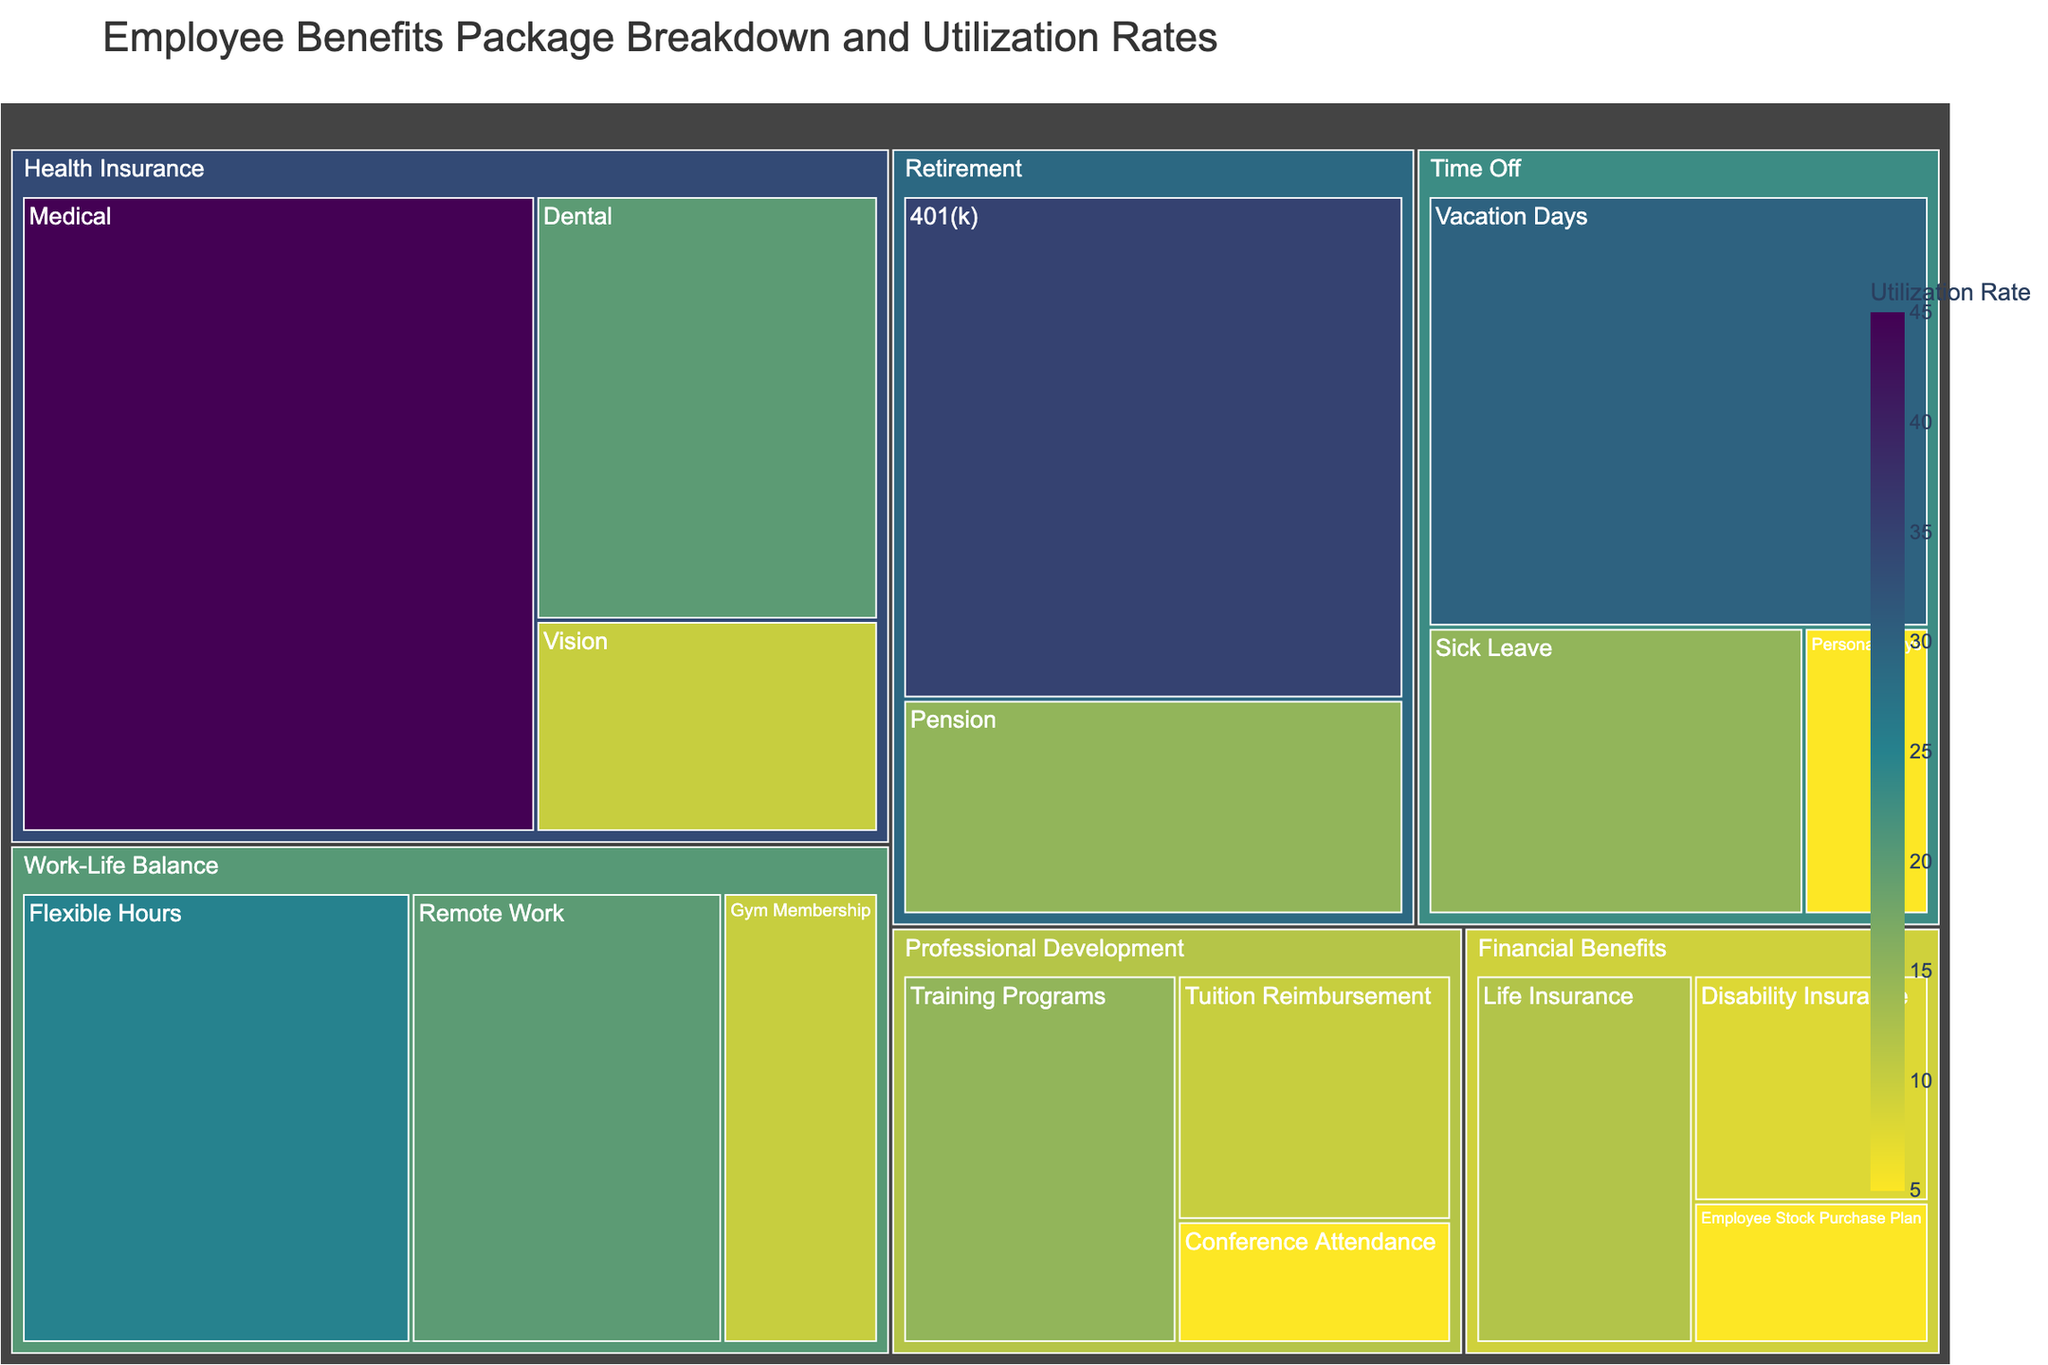What is the Utilization Rate of Medical benefits under Health Insurance? The Medical subcategory under Health Insurance has a Utilization Rate of 45 as shown in the figure.
Answer: 45 Which subcategory under Professional Development has the lowest Utilization Rate? Under Professional Development, Conference Attendance has the lowest Utilization Rate of 5 as depicted in the figure.
Answer: Conference Attendance What is the total Utilization Rate for all subcategories under Retirement? The subcategories under Retirement are 401(k) with 35 and Pension with 15. Summing these gives 35 + 15 = 50.
Answer: 50 Compare the Utilization Rates of Vacation Days and Flexible Hours. Which one is higher? Vacation Days has a Utilization Rate of 30, while Flexible Hours has a Utilization Rate of 25. Therefore, Vacation Days is higher.
Answer: Vacation Days What is the Utilization Rate difference between Dental and Vision benefits under Health Insurance? Dental has a Utilization Rate of 20 and Vision has a Utilization Rate of 10. The difference is 20 - 10 = 10.
Answer: 10 How many subcategories are there under Financial Benefits? The Financial Benefits category includes Life Insurance, Disability Insurance, and Employee Stock Purchase Plan, making a total of 3 subcategories.
Answer: 3 Which category has the highest total Utilization Rate, and what is it? Health Insurance has Medical (45), Dental (20), and Vision (10) totaling 45 + 20 + 10 = 75, which is the highest among the categories.
Answer: Health Insurance; 75 Is the color representing higher Utilization Rates darker or lighter in the Treemap? The color for higher Utilization Rates is darker on the Treemap, following the custom color scale used.
Answer: Darker What is the average Utilization Rate for the subcategories under Time Off? The subcategories under Time Off are Vacation Days (30), Sick Leave (15), and Personal Days (5). The average is (30 + 15 + 5)/3 = 50/3 ≈ 16.67.
Answer: 16.67 Compare the Utilization Rate of Training Programs under Professional Development with Remote Work under Work-Life Balance. Which is higher? Training Programs has a Utilization Rate of 15 and Remote Work has a Utilization Rate of 20. Remote Work is higher.
Answer: Remote Work 